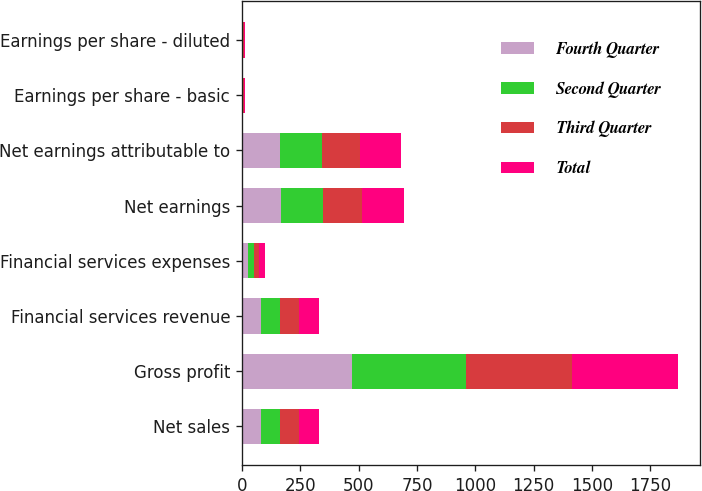Convert chart to OTSL. <chart><loc_0><loc_0><loc_500><loc_500><stacked_bar_chart><ecel><fcel>Net sales<fcel>Gross profit<fcel>Financial services revenue<fcel>Financial services expenses<fcel>Net earnings<fcel>Net earnings attributable to<fcel>Earnings per share - basic<fcel>Earnings per share - diluted<nl><fcel>Fourth Quarter<fcel>82.35<fcel>471.6<fcel>83<fcel>26.1<fcel>166.8<fcel>163<fcel>2.87<fcel>2.82<nl><fcel>Second Quarter<fcel>82.35<fcel>487.1<fcel>82<fcel>24.2<fcel>182.7<fcel>178.7<fcel>3.17<fcel>3.12<nl><fcel>Third Quarter<fcel>82.35<fcel>453.9<fcel>82<fcel>22.7<fcel>167.4<fcel>163.2<fcel>2.9<fcel>2.85<nl><fcel>Total<fcel>82.35<fcel>457.4<fcel>82.7<fcel>26.6<fcel>179.3<fcel>175<fcel>3.14<fcel>3.09<nl></chart> 